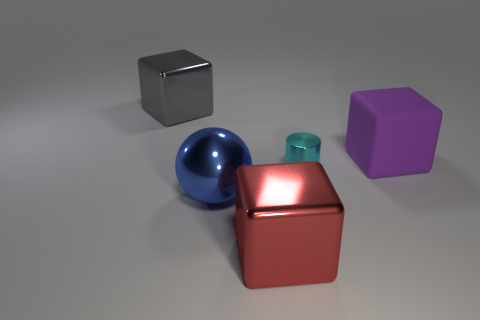Is there anything else that is the same size as the cylinder?
Provide a short and direct response. No. Are there more cylinders that are behind the matte cube than yellow cubes?
Your response must be concise. No. There is a big purple rubber block; how many cubes are on the left side of it?
Make the answer very short. 2. Are there any green metallic balls that have the same size as the purple cube?
Make the answer very short. No. What is the color of the other large matte object that is the same shape as the big gray object?
Offer a very short reply. Purple. Do the metal cube that is on the right side of the large gray cube and the shiny thing right of the red metallic thing have the same size?
Give a very brief answer. No. Are there any other large things of the same shape as the purple matte object?
Ensure brevity in your answer.  Yes. Is the number of metallic blocks that are right of the big rubber block the same as the number of small green metal cubes?
Give a very brief answer. Yes. There is a cyan thing; is it the same size as the cube that is to the right of the big red metal thing?
Offer a terse response. No. What number of gray blocks are made of the same material as the cyan thing?
Make the answer very short. 1. 